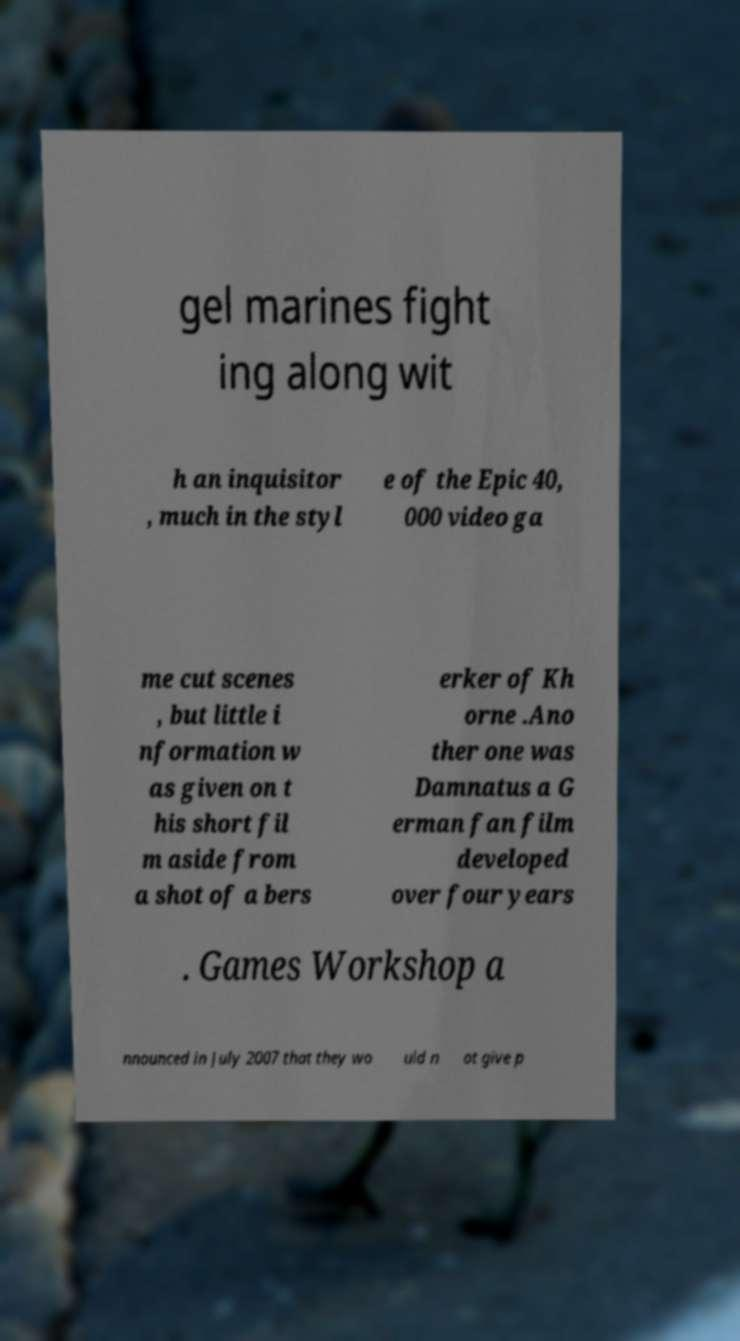Could you assist in decoding the text presented in this image and type it out clearly? gel marines fight ing along wit h an inquisitor , much in the styl e of the Epic 40, 000 video ga me cut scenes , but little i nformation w as given on t his short fil m aside from a shot of a bers erker of Kh orne .Ano ther one was Damnatus a G erman fan film developed over four years . Games Workshop a nnounced in July 2007 that they wo uld n ot give p 